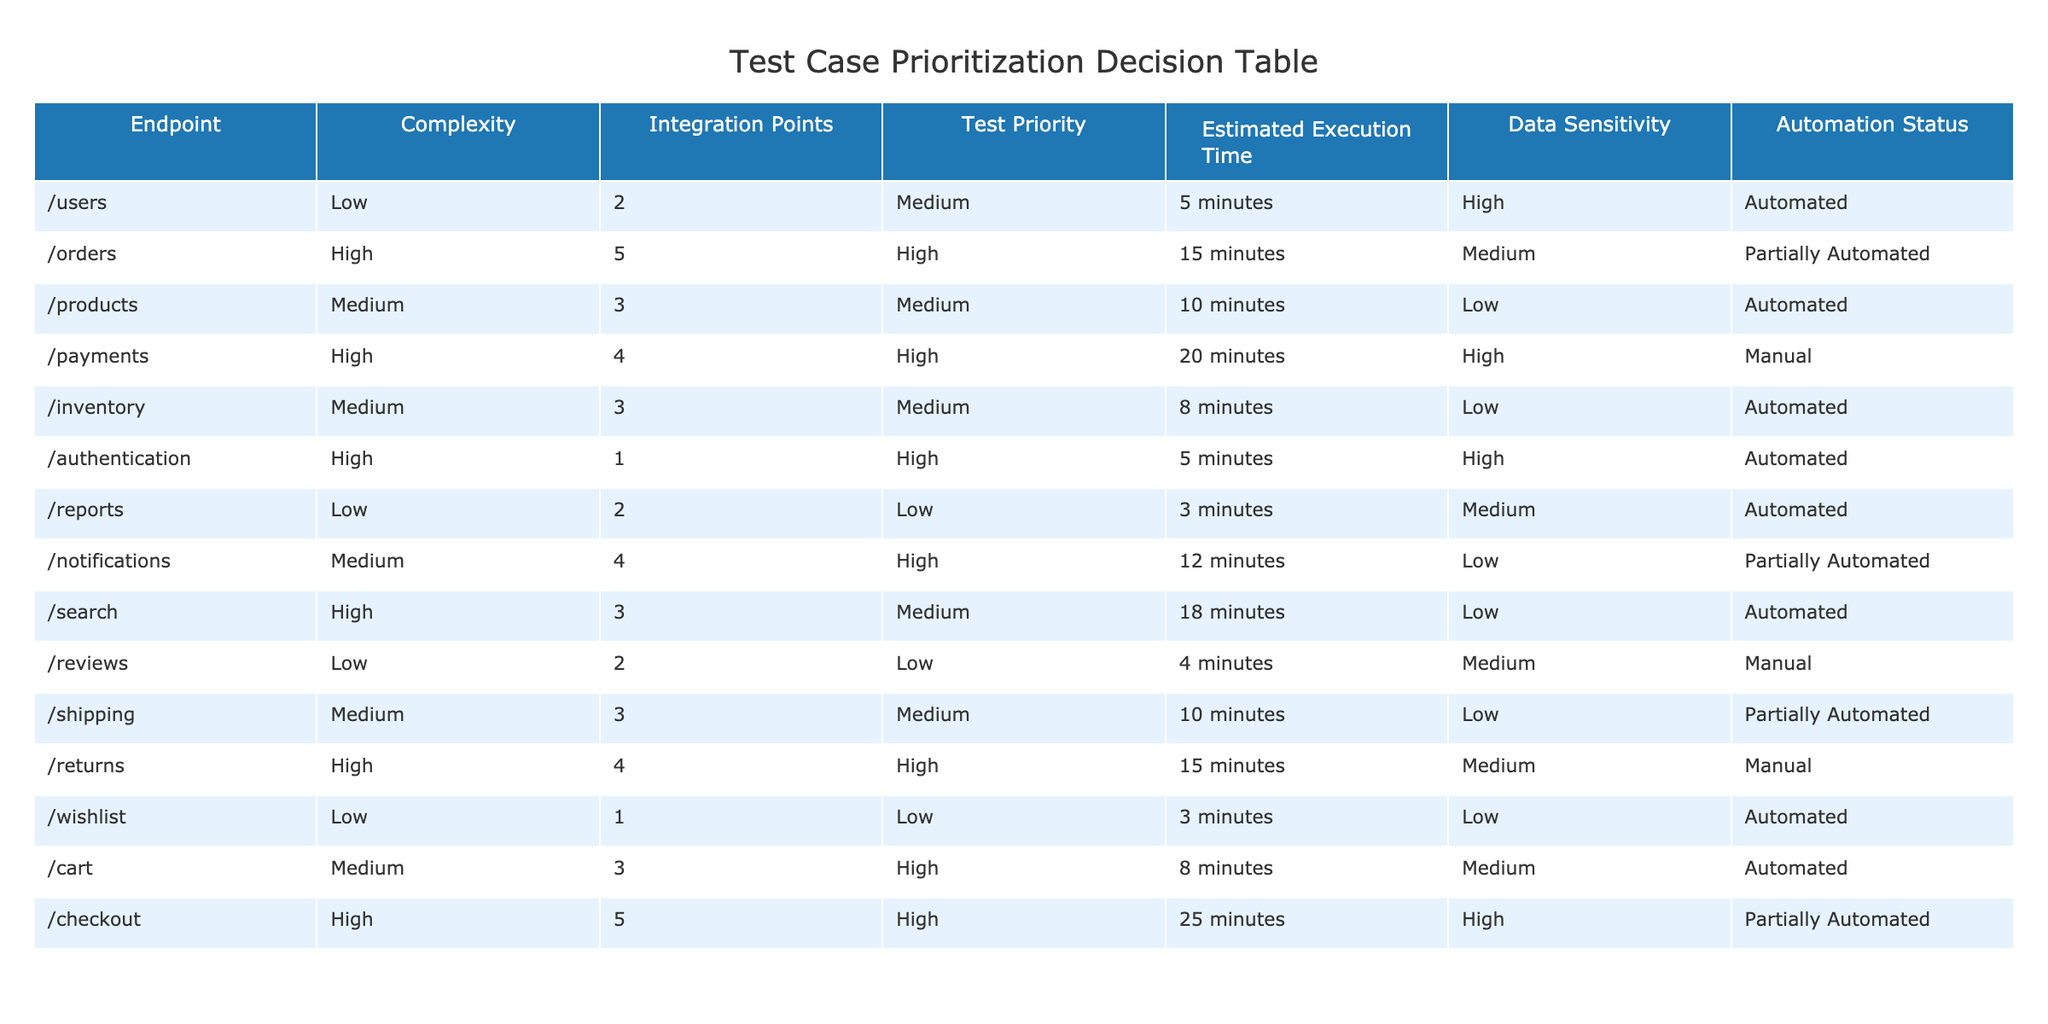What is the estimated execution time for the /orders endpoint? The table lists the estimated execution time for the /orders endpoint directly under that endpoint, which is 15 minutes.
Answer: 15 minutes How many integration points does the /authentication endpoint have? By referring to the column labeled "Integration Points," the /authentication endpoint has 1 integration point as stated in the table.
Answer: 1 Which endpoint has the highest complexity? To find the endpoint with the highest complexity, I look for the "High" value in the Complexity column. The endpoints marked as high complexity are /orders, /payments, /authentication, /search, and /checkout, but /checkout has the highest estimated execution time of 25 minutes, indicating its higher complexity.
Answer: /checkout Is the /returns endpoint automated? The table contains an "Automation Status" column that indicates whether the endpoint is automated or not. The /returns endpoint is marked as "Manual,” meaning it is not automated.
Answer: No What is the average estimated execution time for all endpoints with high test priority? I first identify the endpoints with high test priority: /orders, /payments, /authentication, /notifications, /returns, and /checkout. Their estimated execution times are 15, 20, 5, 12, 15, and 25 minutes respectively. I sum these values: 15 + 20 + 5 + 12 + 15 + 25 = 92. There are 6 endpoints, so I find the average by dividing 92 by 6, which equals approximately 15.33 minutes.
Answer: 15.33 minutes Which endpoints are automated and have high data sensitivity? I evaluate the table by checking the "Automation Status" and "Data Sensitivity" columns to identify endpoints marked as "Automated" and with "High" sensitivity. The endpoints fitting this criterion are /users and /authentication, so I list them.
Answer: /users, /authentication 